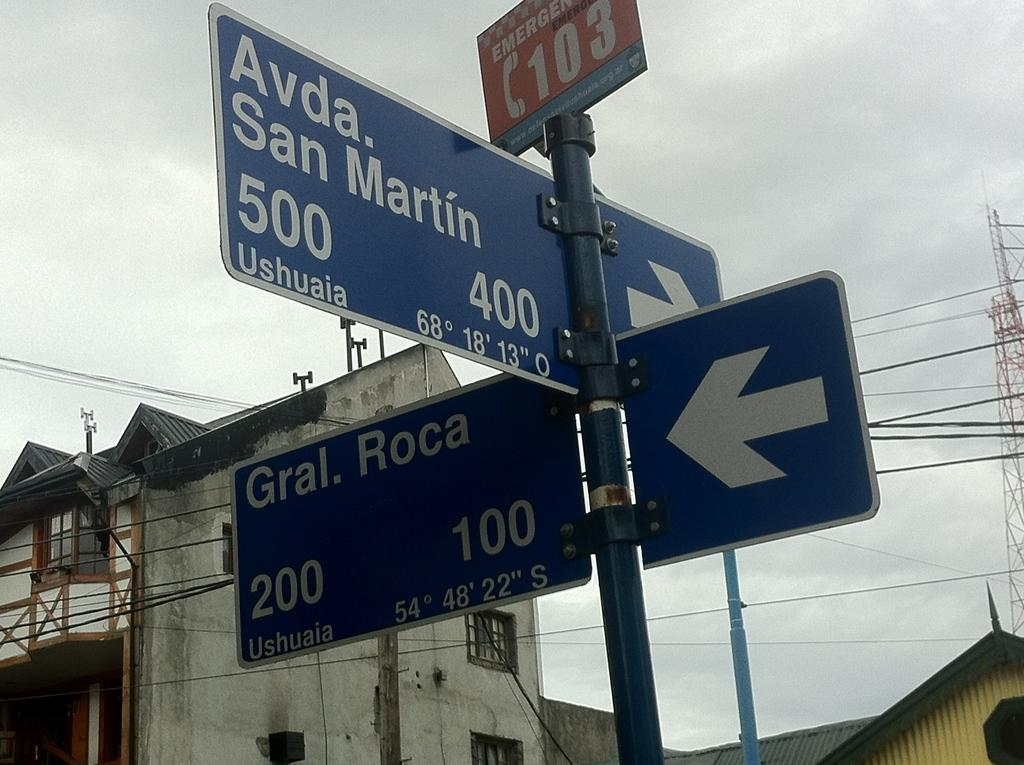Provide a one-sentence caption for the provided image. Multiple road signs with directions to two different streets. 